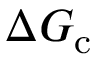Convert formula to latex. <formula><loc_0><loc_0><loc_500><loc_500>\Delta G _ { c }</formula> 